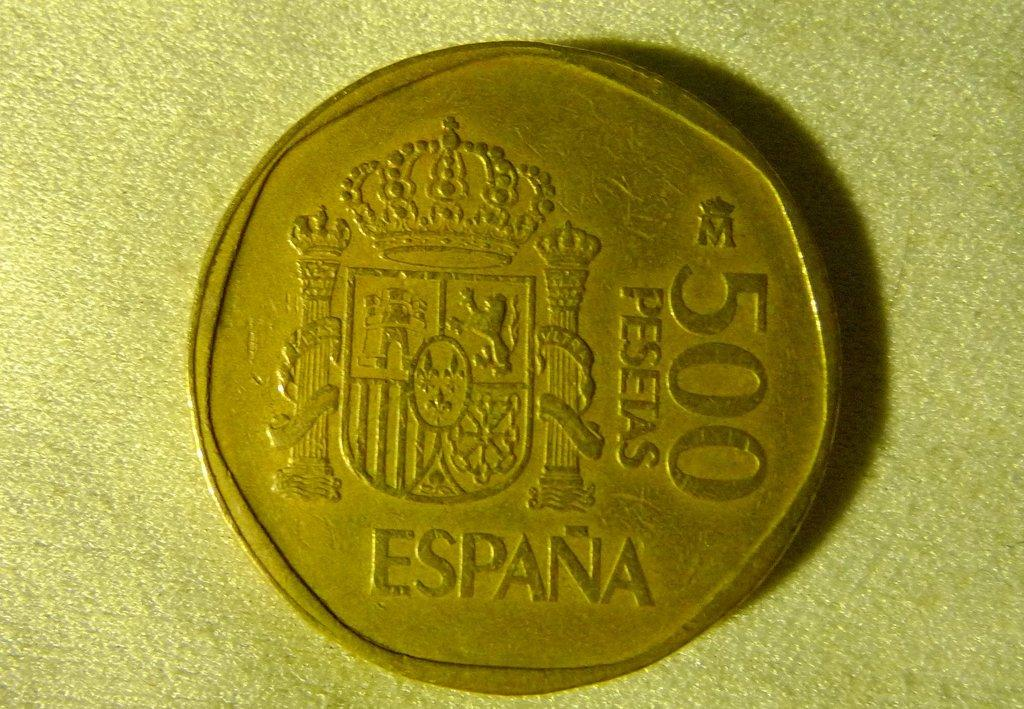<image>
Relay a brief, clear account of the picture shown. A coin that says "Espana" on it is worth 500 pesetas. 